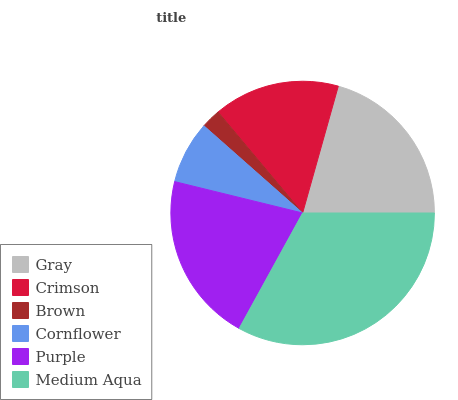Is Brown the minimum?
Answer yes or no. Yes. Is Medium Aqua the maximum?
Answer yes or no. Yes. Is Crimson the minimum?
Answer yes or no. No. Is Crimson the maximum?
Answer yes or no. No. Is Gray greater than Crimson?
Answer yes or no. Yes. Is Crimson less than Gray?
Answer yes or no. Yes. Is Crimson greater than Gray?
Answer yes or no. No. Is Gray less than Crimson?
Answer yes or no. No. Is Gray the high median?
Answer yes or no. Yes. Is Crimson the low median?
Answer yes or no. Yes. Is Cornflower the high median?
Answer yes or no. No. Is Purple the low median?
Answer yes or no. No. 